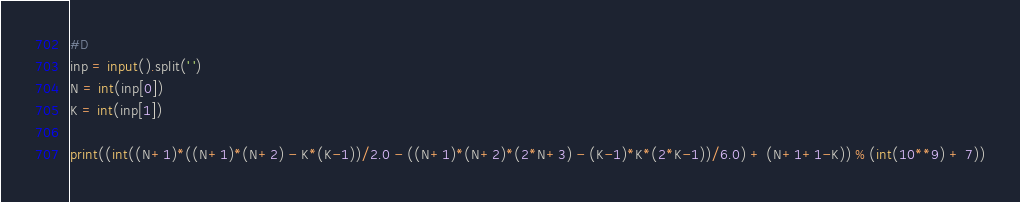<code> <loc_0><loc_0><loc_500><loc_500><_Python_>#D 
inp = input().split(' ')
N = int(inp[0])
K = int(inp[1])

print((int((N+1)*((N+1)*(N+2) - K*(K-1))/2.0 - ((N+1)*(N+2)*(2*N+3) - (K-1)*K*(2*K-1))/6.0) + (N+1+1-K)) % (int(10**9) + 7))</code> 